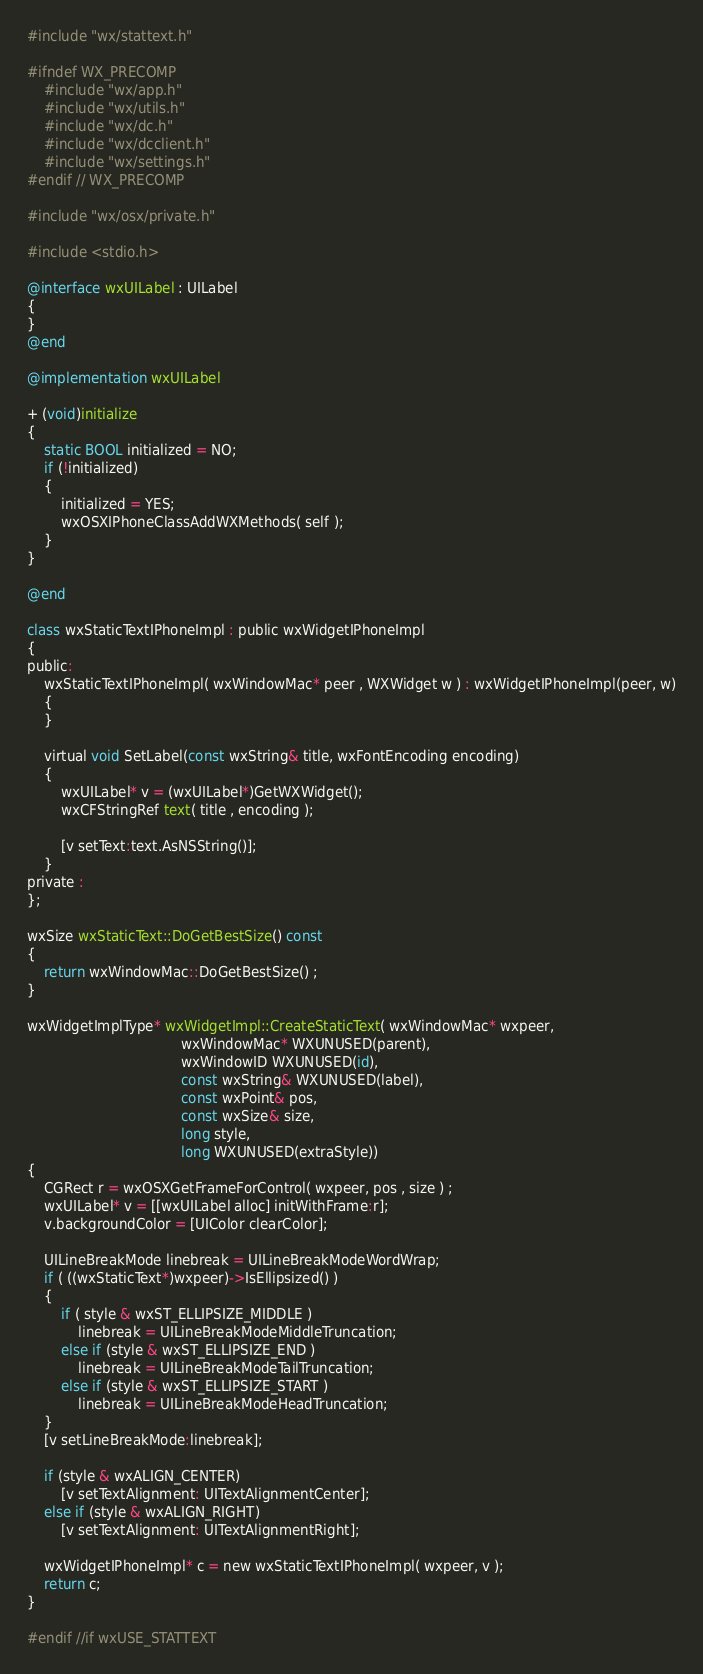<code> <loc_0><loc_0><loc_500><loc_500><_ObjectiveC_>
#include "wx/stattext.h"

#ifndef WX_PRECOMP
    #include "wx/app.h"
    #include "wx/utils.h"
    #include "wx/dc.h"
    #include "wx/dcclient.h"
    #include "wx/settings.h"
#endif // WX_PRECOMP

#include "wx/osx/private.h"

#include <stdio.h>

@interface wxUILabel : UILabel
{
}
@end

@implementation wxUILabel

+ (void)initialize
{
    static BOOL initialized = NO;
    if (!initialized)
    {
        initialized = YES;
        wxOSXIPhoneClassAddWXMethods( self );
    }
}

@end

class wxStaticTextIPhoneImpl : public wxWidgetIPhoneImpl
{
public:
    wxStaticTextIPhoneImpl( wxWindowMac* peer , WXWidget w ) : wxWidgetIPhoneImpl(peer, w)
    {
    }

    virtual void SetLabel(const wxString& title, wxFontEncoding encoding)
    {
        wxUILabel* v = (wxUILabel*)GetWXWidget();
        wxCFStringRef text( title , encoding );
        
        [v setText:text.AsNSString()];
    }
private :
};

wxSize wxStaticText::DoGetBestSize() const
{
    return wxWindowMac::DoGetBestSize() ;
}

wxWidgetImplType* wxWidgetImpl::CreateStaticText( wxWindowMac* wxpeer,
                                    wxWindowMac* WXUNUSED(parent),
                                    wxWindowID WXUNUSED(id),
                                    const wxString& WXUNUSED(label),
                                    const wxPoint& pos,
                                    const wxSize& size,
                                    long style,
                                    long WXUNUSED(extraStyle))
{
    CGRect r = wxOSXGetFrameForControl( wxpeer, pos , size ) ;
    wxUILabel* v = [[wxUILabel alloc] initWithFrame:r];
    v.backgroundColor = [UIColor clearColor];

    UILineBreakMode linebreak = UILineBreakModeWordWrap;
    if ( ((wxStaticText*)wxpeer)->IsEllipsized() )
    {
        if ( style & wxST_ELLIPSIZE_MIDDLE )
            linebreak = UILineBreakModeMiddleTruncation;
        else if (style & wxST_ELLIPSIZE_END )
            linebreak = UILineBreakModeTailTruncation;
        else if (style & wxST_ELLIPSIZE_START )
            linebreak = UILineBreakModeHeadTruncation;
    }
    [v setLineBreakMode:linebreak];

    if (style & wxALIGN_CENTER)
        [v setTextAlignment: UITextAlignmentCenter];
    else if (style & wxALIGN_RIGHT)
        [v setTextAlignment: UITextAlignmentRight];
    
    wxWidgetIPhoneImpl* c = new wxStaticTextIPhoneImpl( wxpeer, v );
    return c;
}

#endif //if wxUSE_STATTEXT
</code> 